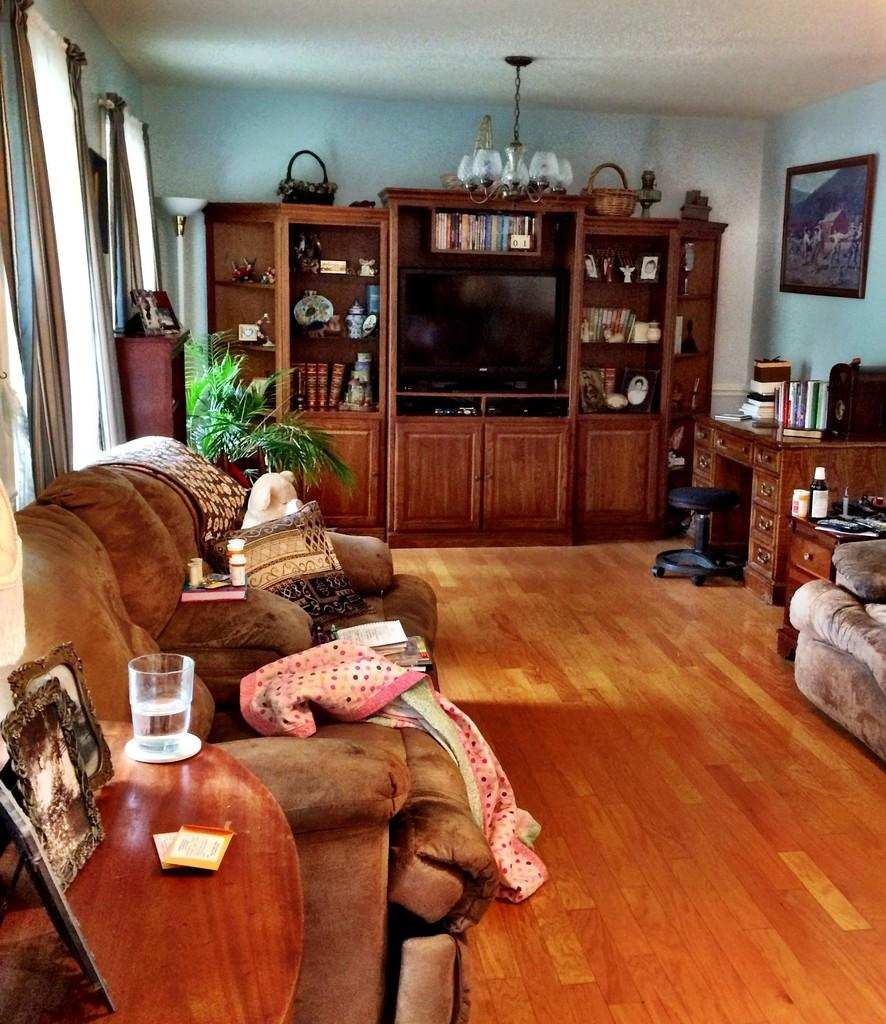What is the color of the wall in the image? The wall in the image is white. What furniture piece can be seen in the image? There is a rack, a table, and a sofa in the image. What type of lighting is present in the image? There are lights in the image. What type of storage containers are in the image? There are baskets in the image. What type of seating is available in the image? There is a sofa in the image. What type of decorative items are on the table? There are photo frames and a glass on the table. What type of cushioning is present in the image? There are pillows in the image. Where is the bomb located in the image? There is no bomb present in the image. What type of bead is used as a decoration on the sofa? There are no beads used as decoration on the sofa in the image. 